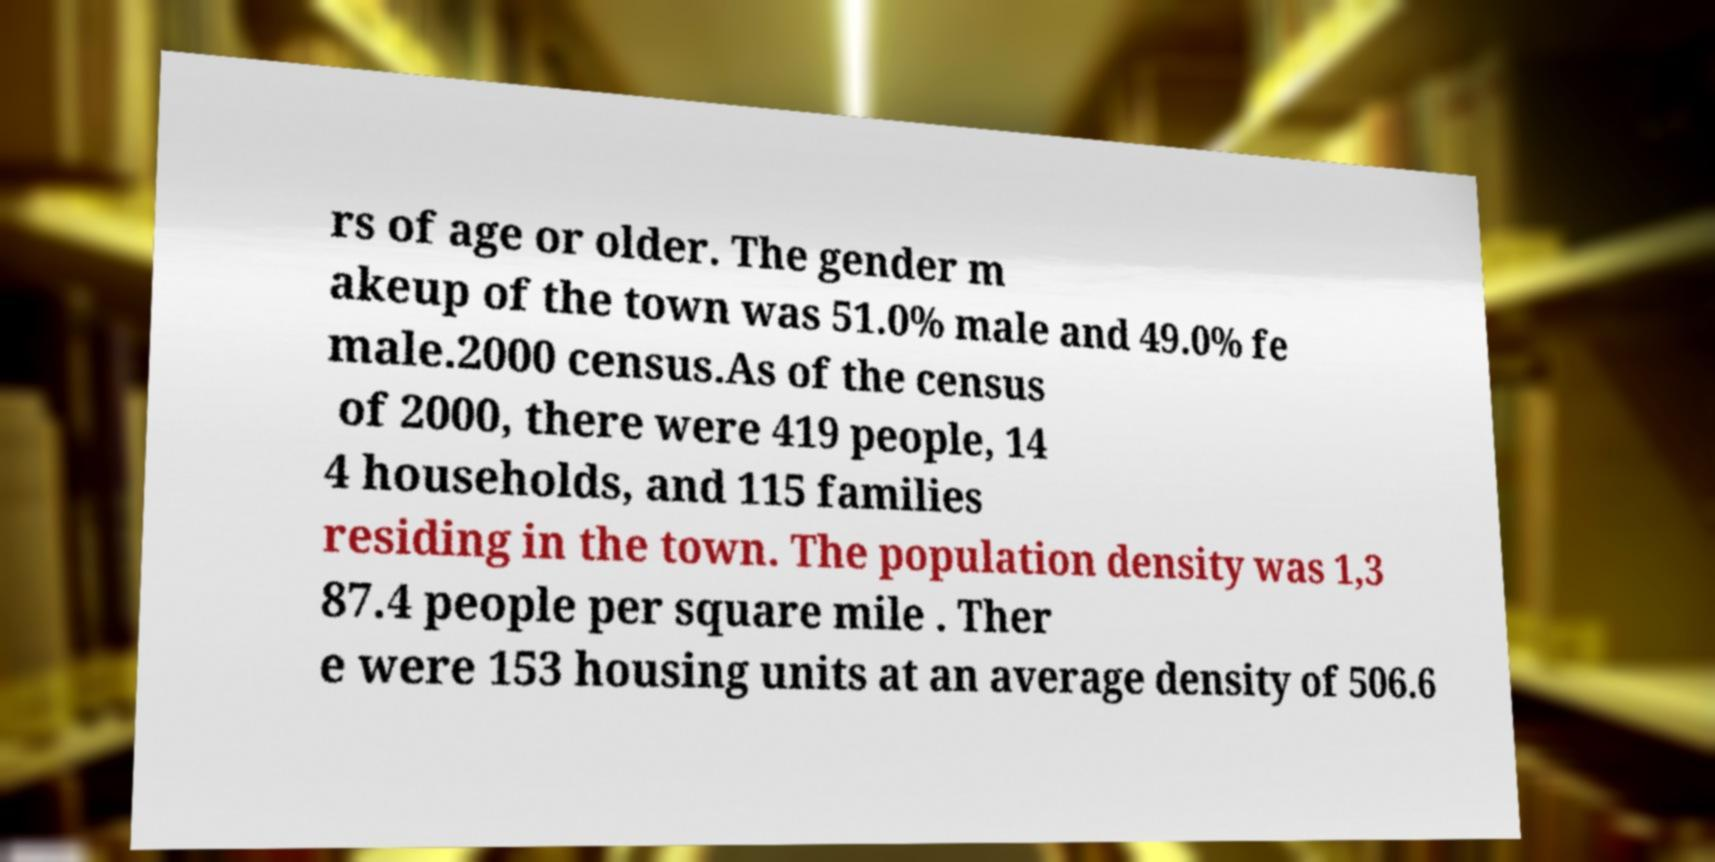Can you read and provide the text displayed in the image?This photo seems to have some interesting text. Can you extract and type it out for me? rs of age or older. The gender m akeup of the town was 51.0% male and 49.0% fe male.2000 census.As of the census of 2000, there were 419 people, 14 4 households, and 115 families residing in the town. The population density was 1,3 87.4 people per square mile . Ther e were 153 housing units at an average density of 506.6 